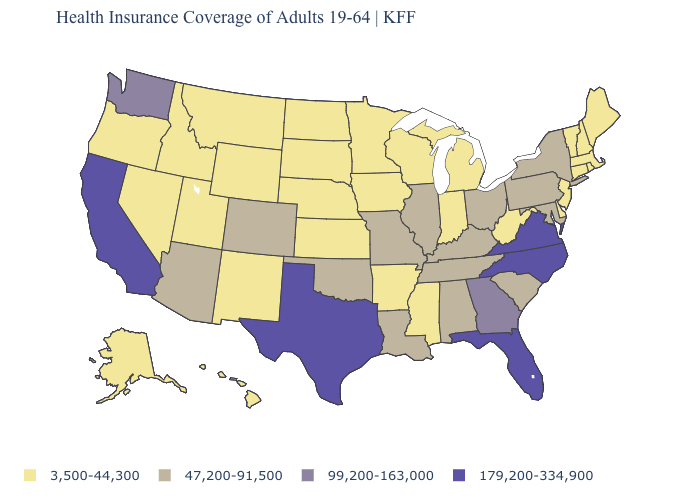What is the value of Missouri?
Concise answer only. 47,200-91,500. Is the legend a continuous bar?
Be succinct. No. What is the value of Rhode Island?
Quick response, please. 3,500-44,300. Which states have the highest value in the USA?
Write a very short answer. California, Florida, North Carolina, Texas, Virginia. Which states have the highest value in the USA?
Answer briefly. California, Florida, North Carolina, Texas, Virginia. Name the states that have a value in the range 99,200-163,000?
Concise answer only. Georgia, Washington. What is the lowest value in the USA?
Keep it brief. 3,500-44,300. Does West Virginia have a lower value than Florida?
Be succinct. Yes. What is the value of California?
Quick response, please. 179,200-334,900. What is the value of South Dakota?
Give a very brief answer. 3,500-44,300. Does Louisiana have the lowest value in the USA?
Give a very brief answer. No. What is the value of Rhode Island?
Short answer required. 3,500-44,300. Does Mississippi have the same value as Louisiana?
Answer briefly. No. Name the states that have a value in the range 99,200-163,000?
Concise answer only. Georgia, Washington. Does Pennsylvania have a higher value than Kentucky?
Short answer required. No. 